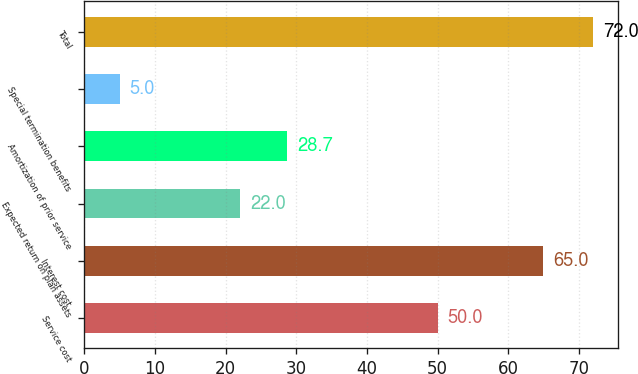<chart> <loc_0><loc_0><loc_500><loc_500><bar_chart><fcel>Service cost<fcel>Interest cost<fcel>Expected return on plan assets<fcel>Amortization of prior service<fcel>Special termination benefits<fcel>Total<nl><fcel>50<fcel>65<fcel>22<fcel>28.7<fcel>5<fcel>72<nl></chart> 